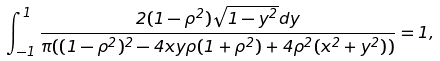<formula> <loc_0><loc_0><loc_500><loc_500>\int _ { - 1 } ^ { 1 } \frac { 2 ( 1 - \rho ^ { 2 } ) \sqrt { 1 - y ^ { 2 } } d y } { \pi ( ( 1 - \rho ^ { 2 } ) ^ { 2 } - 4 x y \rho ( 1 + \rho ^ { 2 } ) + 4 \rho ^ { 2 } ( x ^ { 2 } + y ^ { 2 } ) ) } = 1 ,</formula> 